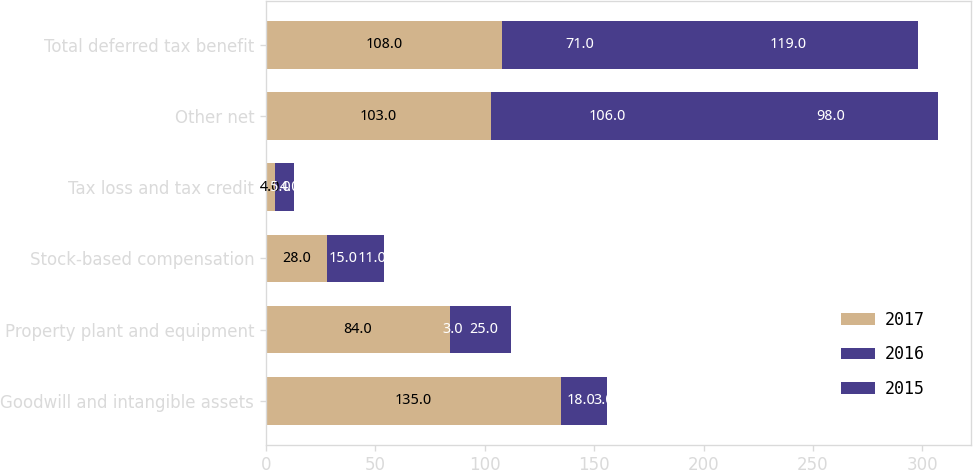<chart> <loc_0><loc_0><loc_500><loc_500><stacked_bar_chart><ecel><fcel>Goodwill and intangible assets<fcel>Property plant and equipment<fcel>Stock-based compensation<fcel>Tax loss and tax credit<fcel>Other net<fcel>Total deferred tax benefit<nl><fcel>2017<fcel>135<fcel>84<fcel>28<fcel>4<fcel>103<fcel>108<nl><fcel>2016<fcel>18<fcel>3<fcel>15<fcel>5<fcel>106<fcel>71<nl><fcel>2015<fcel>3<fcel>25<fcel>11<fcel>4<fcel>98<fcel>119<nl></chart> 